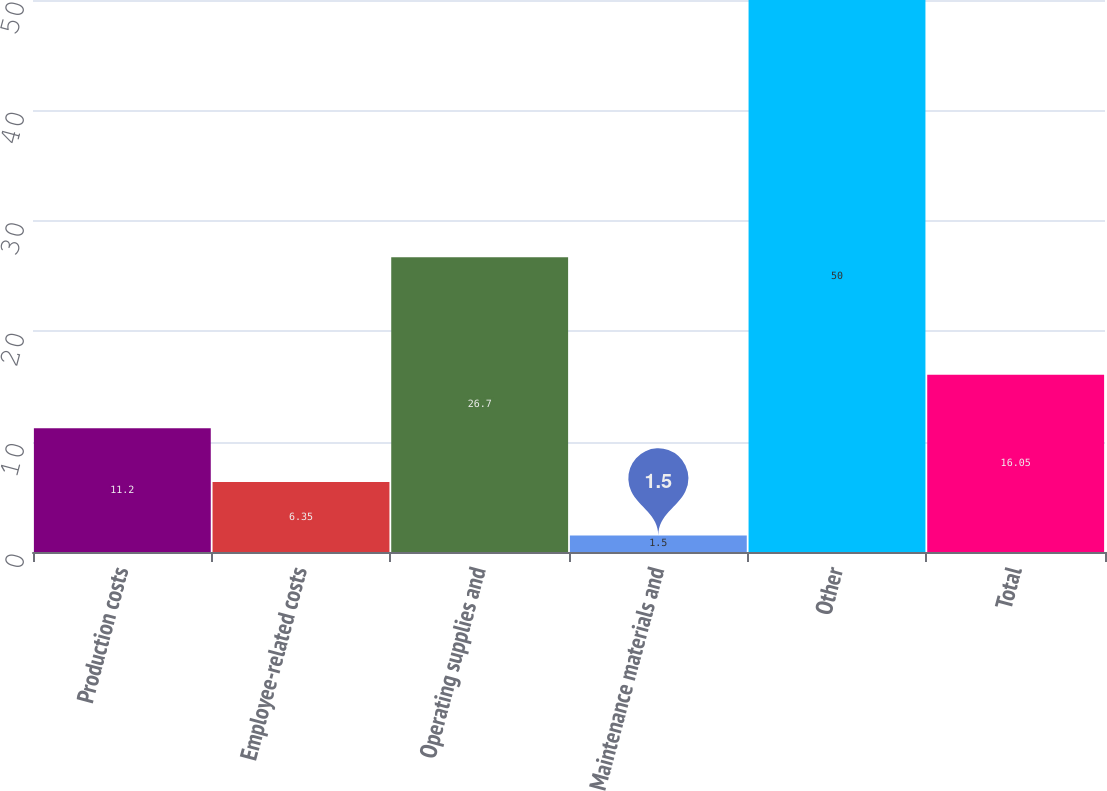Convert chart. <chart><loc_0><loc_0><loc_500><loc_500><bar_chart><fcel>Production costs<fcel>Employee-related costs<fcel>Operating supplies and<fcel>Maintenance materials and<fcel>Other<fcel>Total<nl><fcel>11.2<fcel>6.35<fcel>26.7<fcel>1.5<fcel>50<fcel>16.05<nl></chart> 